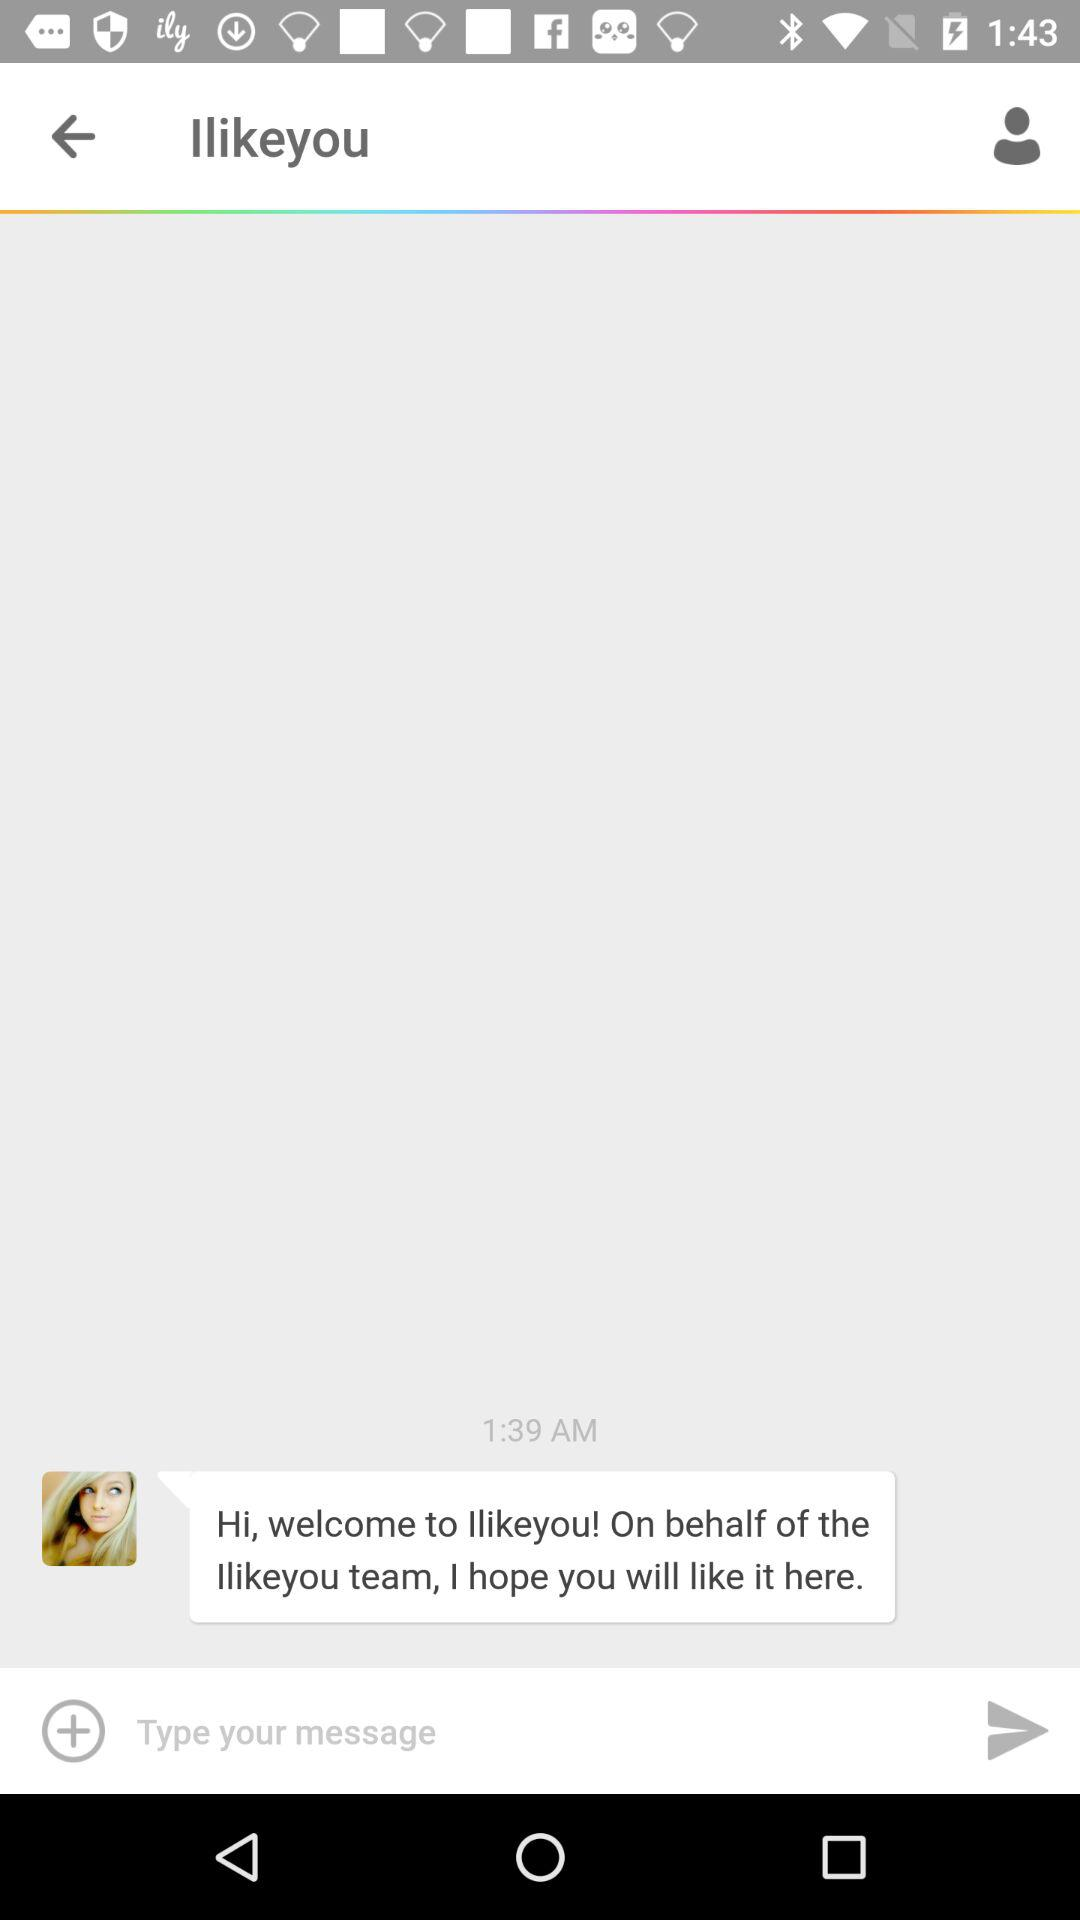What is the name of the application? The name of the application is "Ilikeyou". 